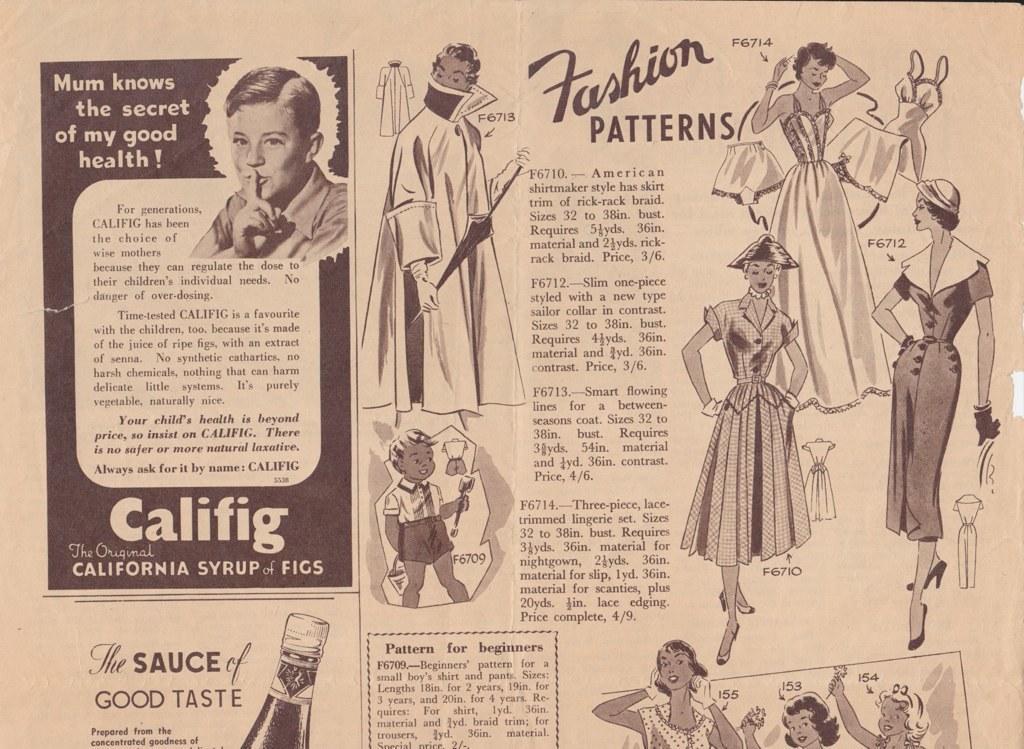Please provide a concise description of this image. This image consists of a newspaper. In which there is a text and pictures of many persons. 